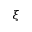Convert formula to latex. <formula><loc_0><loc_0><loc_500><loc_500>\xi</formula> 